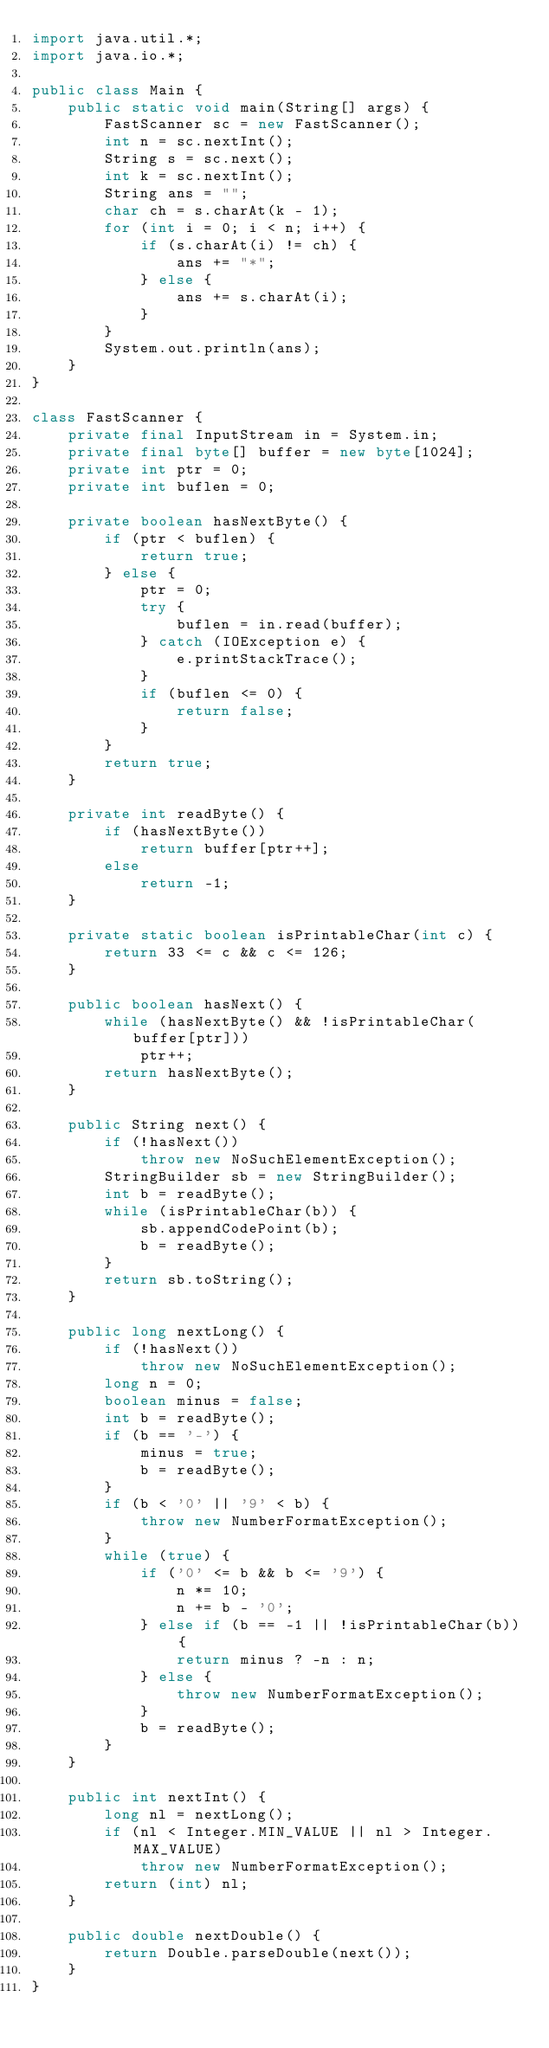Convert code to text. <code><loc_0><loc_0><loc_500><loc_500><_Java_>import java.util.*;
import java.io.*;

public class Main {
    public static void main(String[] args) {
        FastScanner sc = new FastScanner();
        int n = sc.nextInt();
        String s = sc.next();
        int k = sc.nextInt();
        String ans = "";
        char ch = s.charAt(k - 1);
        for (int i = 0; i < n; i++) {
            if (s.charAt(i) != ch) {
                ans += "*";
            } else {
                ans += s.charAt(i);
            }
        }
        System.out.println(ans);
    }
}

class FastScanner {
    private final InputStream in = System.in;
    private final byte[] buffer = new byte[1024];
    private int ptr = 0;
    private int buflen = 0;

    private boolean hasNextByte() {
        if (ptr < buflen) {
            return true;
        } else {
            ptr = 0;
            try {
                buflen = in.read(buffer);
            } catch (IOException e) {
                e.printStackTrace();
            }
            if (buflen <= 0) {
                return false;
            }
        }
        return true;
    }

    private int readByte() {
        if (hasNextByte())
            return buffer[ptr++];
        else
            return -1;
    }

    private static boolean isPrintableChar(int c) {
        return 33 <= c && c <= 126;
    }

    public boolean hasNext() {
        while (hasNextByte() && !isPrintableChar(buffer[ptr]))
            ptr++;
        return hasNextByte();
    }

    public String next() {
        if (!hasNext())
            throw new NoSuchElementException();
        StringBuilder sb = new StringBuilder();
        int b = readByte();
        while (isPrintableChar(b)) {
            sb.appendCodePoint(b);
            b = readByte();
        }
        return sb.toString();
    }

    public long nextLong() {
        if (!hasNext())
            throw new NoSuchElementException();
        long n = 0;
        boolean minus = false;
        int b = readByte();
        if (b == '-') {
            minus = true;
            b = readByte();
        }
        if (b < '0' || '9' < b) {
            throw new NumberFormatException();
        }
        while (true) {
            if ('0' <= b && b <= '9') {
                n *= 10;
                n += b - '0';
            } else if (b == -1 || !isPrintableChar(b)) {
                return minus ? -n : n;
            } else {
                throw new NumberFormatException();
            }
            b = readByte();
        }
    }

    public int nextInt() {
        long nl = nextLong();
        if (nl < Integer.MIN_VALUE || nl > Integer.MAX_VALUE)
            throw new NumberFormatException();
        return (int) nl;
    }

    public double nextDouble() {
        return Double.parseDouble(next());
    }
}
</code> 